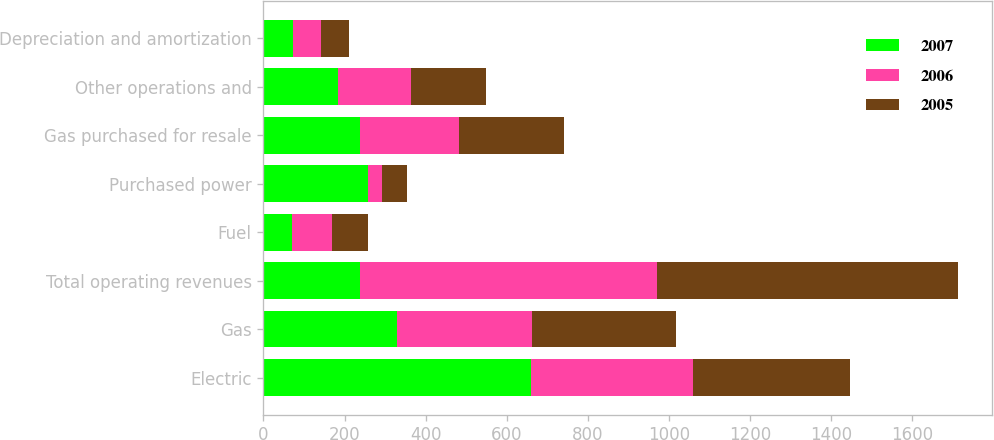Convert chart to OTSL. <chart><loc_0><loc_0><loc_500><loc_500><stacked_bar_chart><ecel><fcel>Electric<fcel>Gas<fcel>Total operating revenues<fcel>Fuel<fcel>Purchased power<fcel>Gas purchased for resale<fcel>Other operations and<fcel>Depreciation and amortization<nl><fcel>2007<fcel>660<fcel>329<fcel>237<fcel>71<fcel>258<fcel>237<fcel>184<fcel>73<nl><fcel>2006<fcel>399<fcel>333<fcel>733<fcel>99<fcel>34<fcel>246<fcel>180<fcel>70<nl><fcel>2005<fcel>387<fcel>355<fcel>742<fcel>87<fcel>63<fcel>258<fcel>184<fcel>67<nl></chart> 